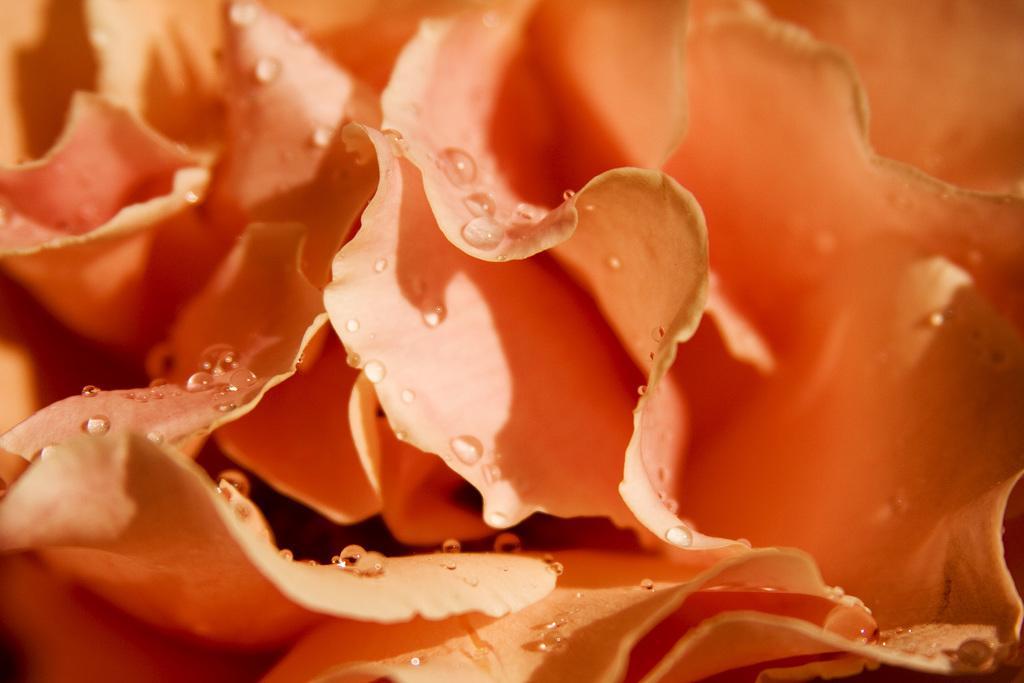Please provide a concise description of this image. In this image we can see flowers and water drops on the flowers. 